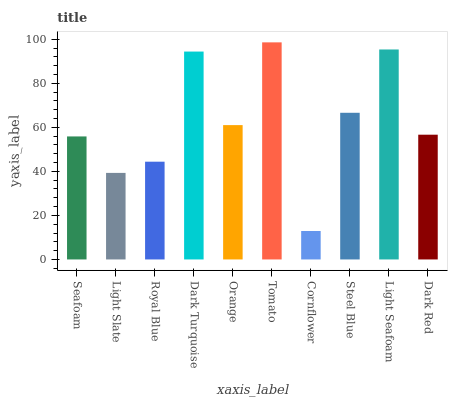Is Cornflower the minimum?
Answer yes or no. Yes. Is Tomato the maximum?
Answer yes or no. Yes. Is Light Slate the minimum?
Answer yes or no. No. Is Light Slate the maximum?
Answer yes or no. No. Is Seafoam greater than Light Slate?
Answer yes or no. Yes. Is Light Slate less than Seafoam?
Answer yes or no. Yes. Is Light Slate greater than Seafoam?
Answer yes or no. No. Is Seafoam less than Light Slate?
Answer yes or no. No. Is Orange the high median?
Answer yes or no. Yes. Is Dark Red the low median?
Answer yes or no. Yes. Is Dark Turquoise the high median?
Answer yes or no. No. Is Tomato the low median?
Answer yes or no. No. 